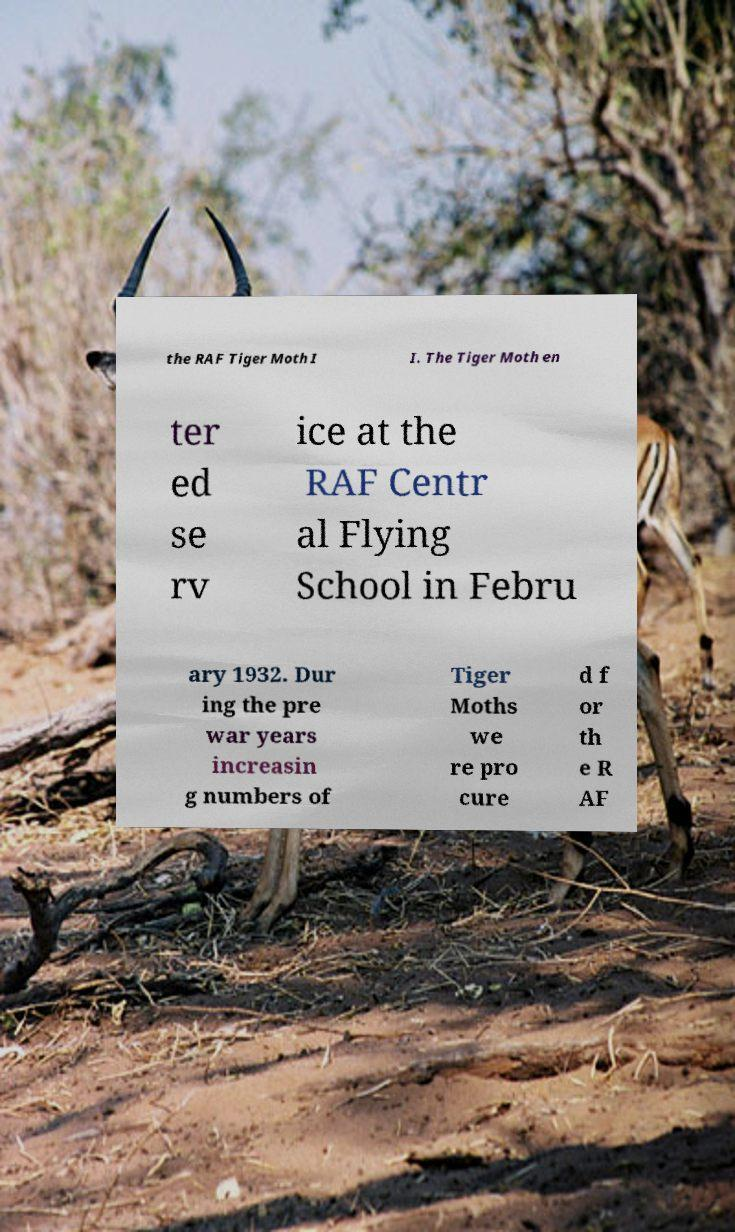What messages or text are displayed in this image? I need them in a readable, typed format. the RAF Tiger Moth I I. The Tiger Moth en ter ed se rv ice at the RAF Centr al Flying School in Febru ary 1932. Dur ing the pre war years increasin g numbers of Tiger Moths we re pro cure d f or th e R AF 